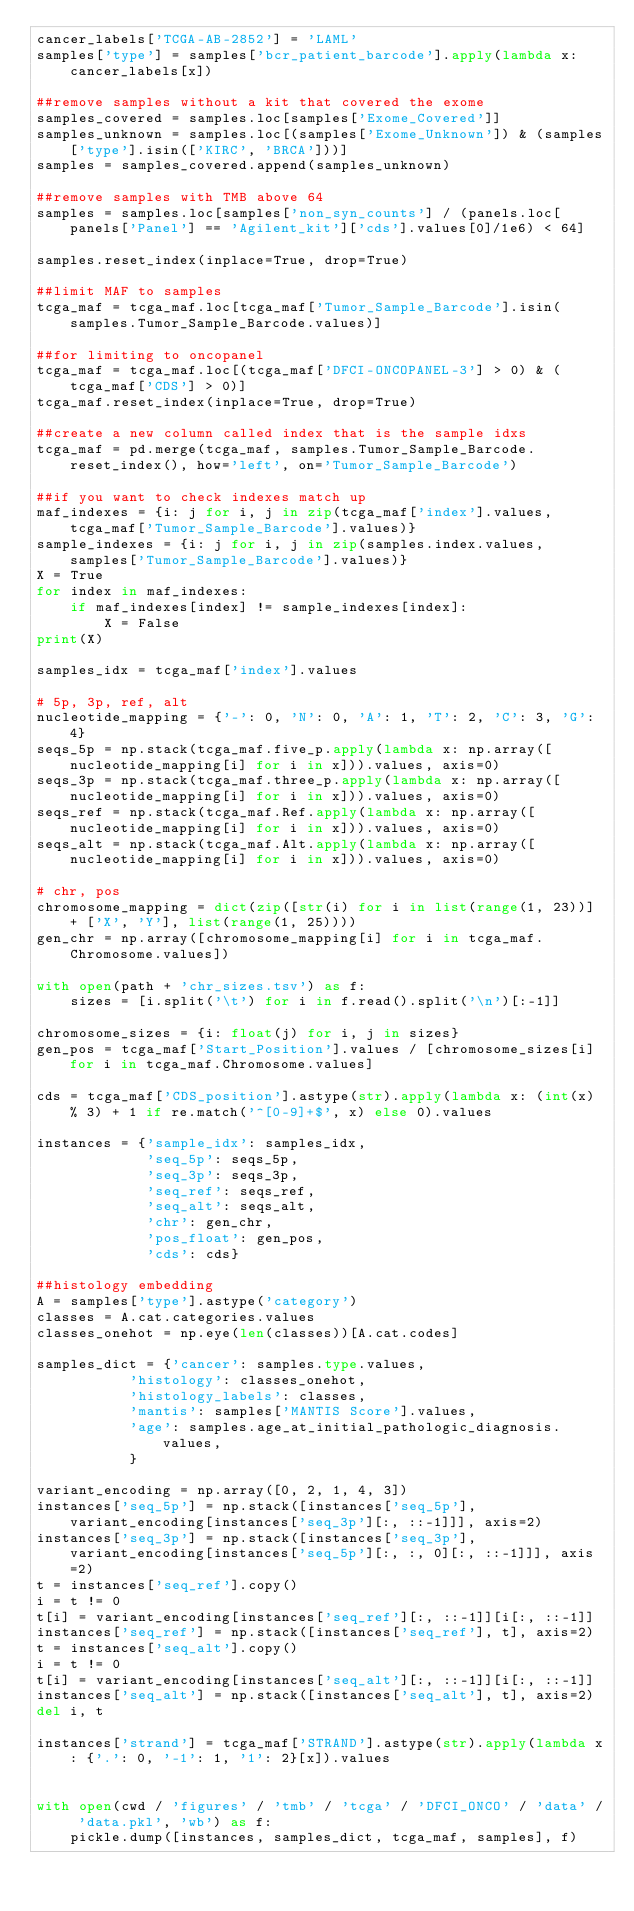Convert code to text. <code><loc_0><loc_0><loc_500><loc_500><_Python_>cancer_labels['TCGA-AB-2852'] = 'LAML'
samples['type'] = samples['bcr_patient_barcode'].apply(lambda x: cancer_labels[x])

##remove samples without a kit that covered the exome
samples_covered = samples.loc[samples['Exome_Covered']]
samples_unknown = samples.loc[(samples['Exome_Unknown']) & (samples['type'].isin(['KIRC', 'BRCA']))]
samples = samples_covered.append(samples_unknown)

##remove samples with TMB above 64
samples = samples.loc[samples['non_syn_counts'] / (panels.loc[panels['Panel'] == 'Agilent_kit']['cds'].values[0]/1e6) < 64]

samples.reset_index(inplace=True, drop=True)

##limit MAF to samples
tcga_maf = tcga_maf.loc[tcga_maf['Tumor_Sample_Barcode'].isin(samples.Tumor_Sample_Barcode.values)]

##for limiting to oncopanel
tcga_maf = tcga_maf.loc[(tcga_maf['DFCI-ONCOPANEL-3'] > 0) & (tcga_maf['CDS'] > 0)]
tcga_maf.reset_index(inplace=True, drop=True)

##create a new column called index that is the sample idxs
tcga_maf = pd.merge(tcga_maf, samples.Tumor_Sample_Barcode.reset_index(), how='left', on='Tumor_Sample_Barcode')

##if you want to check indexes match up
maf_indexes = {i: j for i, j in zip(tcga_maf['index'].values, tcga_maf['Tumor_Sample_Barcode'].values)}
sample_indexes = {i: j for i, j in zip(samples.index.values, samples['Tumor_Sample_Barcode'].values)}
X = True
for index in maf_indexes:
    if maf_indexes[index] != sample_indexes[index]:
        X = False
print(X)

samples_idx = tcga_maf['index'].values

# 5p, 3p, ref, alt
nucleotide_mapping = {'-': 0, 'N': 0, 'A': 1, 'T': 2, 'C': 3, 'G': 4}
seqs_5p = np.stack(tcga_maf.five_p.apply(lambda x: np.array([nucleotide_mapping[i] for i in x])).values, axis=0)
seqs_3p = np.stack(tcga_maf.three_p.apply(lambda x: np.array([nucleotide_mapping[i] for i in x])).values, axis=0)
seqs_ref = np.stack(tcga_maf.Ref.apply(lambda x: np.array([nucleotide_mapping[i] for i in x])).values, axis=0)
seqs_alt = np.stack(tcga_maf.Alt.apply(lambda x: np.array([nucleotide_mapping[i] for i in x])).values, axis=0)

# chr, pos
chromosome_mapping = dict(zip([str(i) for i in list(range(1, 23))] + ['X', 'Y'], list(range(1, 25))))
gen_chr = np.array([chromosome_mapping[i] for i in tcga_maf.Chromosome.values])

with open(path + 'chr_sizes.tsv') as f:
    sizes = [i.split('\t') for i in f.read().split('\n')[:-1]]

chromosome_sizes = {i: float(j) for i, j in sizes}
gen_pos = tcga_maf['Start_Position'].values / [chromosome_sizes[i] for i in tcga_maf.Chromosome.values]

cds = tcga_maf['CDS_position'].astype(str).apply(lambda x: (int(x) % 3) + 1 if re.match('^[0-9]+$', x) else 0).values

instances = {'sample_idx': samples_idx,
             'seq_5p': seqs_5p,
             'seq_3p': seqs_3p,
             'seq_ref': seqs_ref,
             'seq_alt': seqs_alt,
             'chr': gen_chr,
             'pos_float': gen_pos,
             'cds': cds}

##histology embedding
A = samples['type'].astype('category')
classes = A.cat.categories.values
classes_onehot = np.eye(len(classes))[A.cat.codes]

samples_dict = {'cancer': samples.type.values,
           'histology': classes_onehot,
           'histology_labels': classes,
           'mantis': samples['MANTIS Score'].values,
           'age': samples.age_at_initial_pathologic_diagnosis.values,
           }

variant_encoding = np.array([0, 2, 1, 4, 3])
instances['seq_5p'] = np.stack([instances['seq_5p'], variant_encoding[instances['seq_3p'][:, ::-1]]], axis=2)
instances['seq_3p'] = np.stack([instances['seq_3p'], variant_encoding[instances['seq_5p'][:, :, 0][:, ::-1]]], axis=2)
t = instances['seq_ref'].copy()
i = t != 0
t[i] = variant_encoding[instances['seq_ref'][:, ::-1]][i[:, ::-1]]
instances['seq_ref'] = np.stack([instances['seq_ref'], t], axis=2)
t = instances['seq_alt'].copy()
i = t != 0
t[i] = variant_encoding[instances['seq_alt'][:, ::-1]][i[:, ::-1]]
instances['seq_alt'] = np.stack([instances['seq_alt'], t], axis=2)
del i, t

instances['strand'] = tcga_maf['STRAND'].astype(str).apply(lambda x: {'.': 0, '-1': 1, '1': 2}[x]).values


with open(cwd / 'figures' / 'tmb' / 'tcga' / 'DFCI_ONCO' / 'data' / 'data.pkl', 'wb') as f:
    pickle.dump([instances, samples_dict, tcga_maf, samples], f)

</code> 